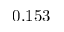Convert formula to latex. <formula><loc_0><loc_0><loc_500><loc_500>0 . 1 5 3</formula> 